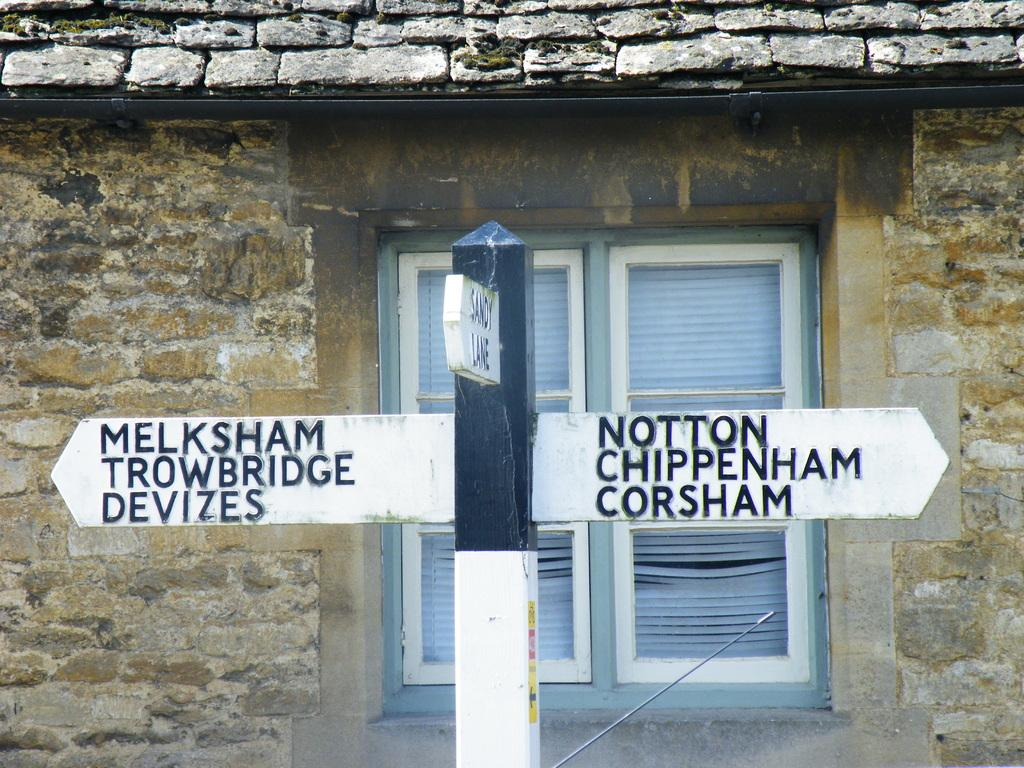What is the main object in the image? There is a directional sign board in the image. How is the sign board positioned in the image? The sign board is attached to a pole. What type of house can be seen in the image? There is a house with bricks in the image. What feature of the house is visible in the image? The house has a window. How many toads are sitting on the roof of the house in the image? There are no toads present in the image; the focus is on the directional sign board and the house with a window. 